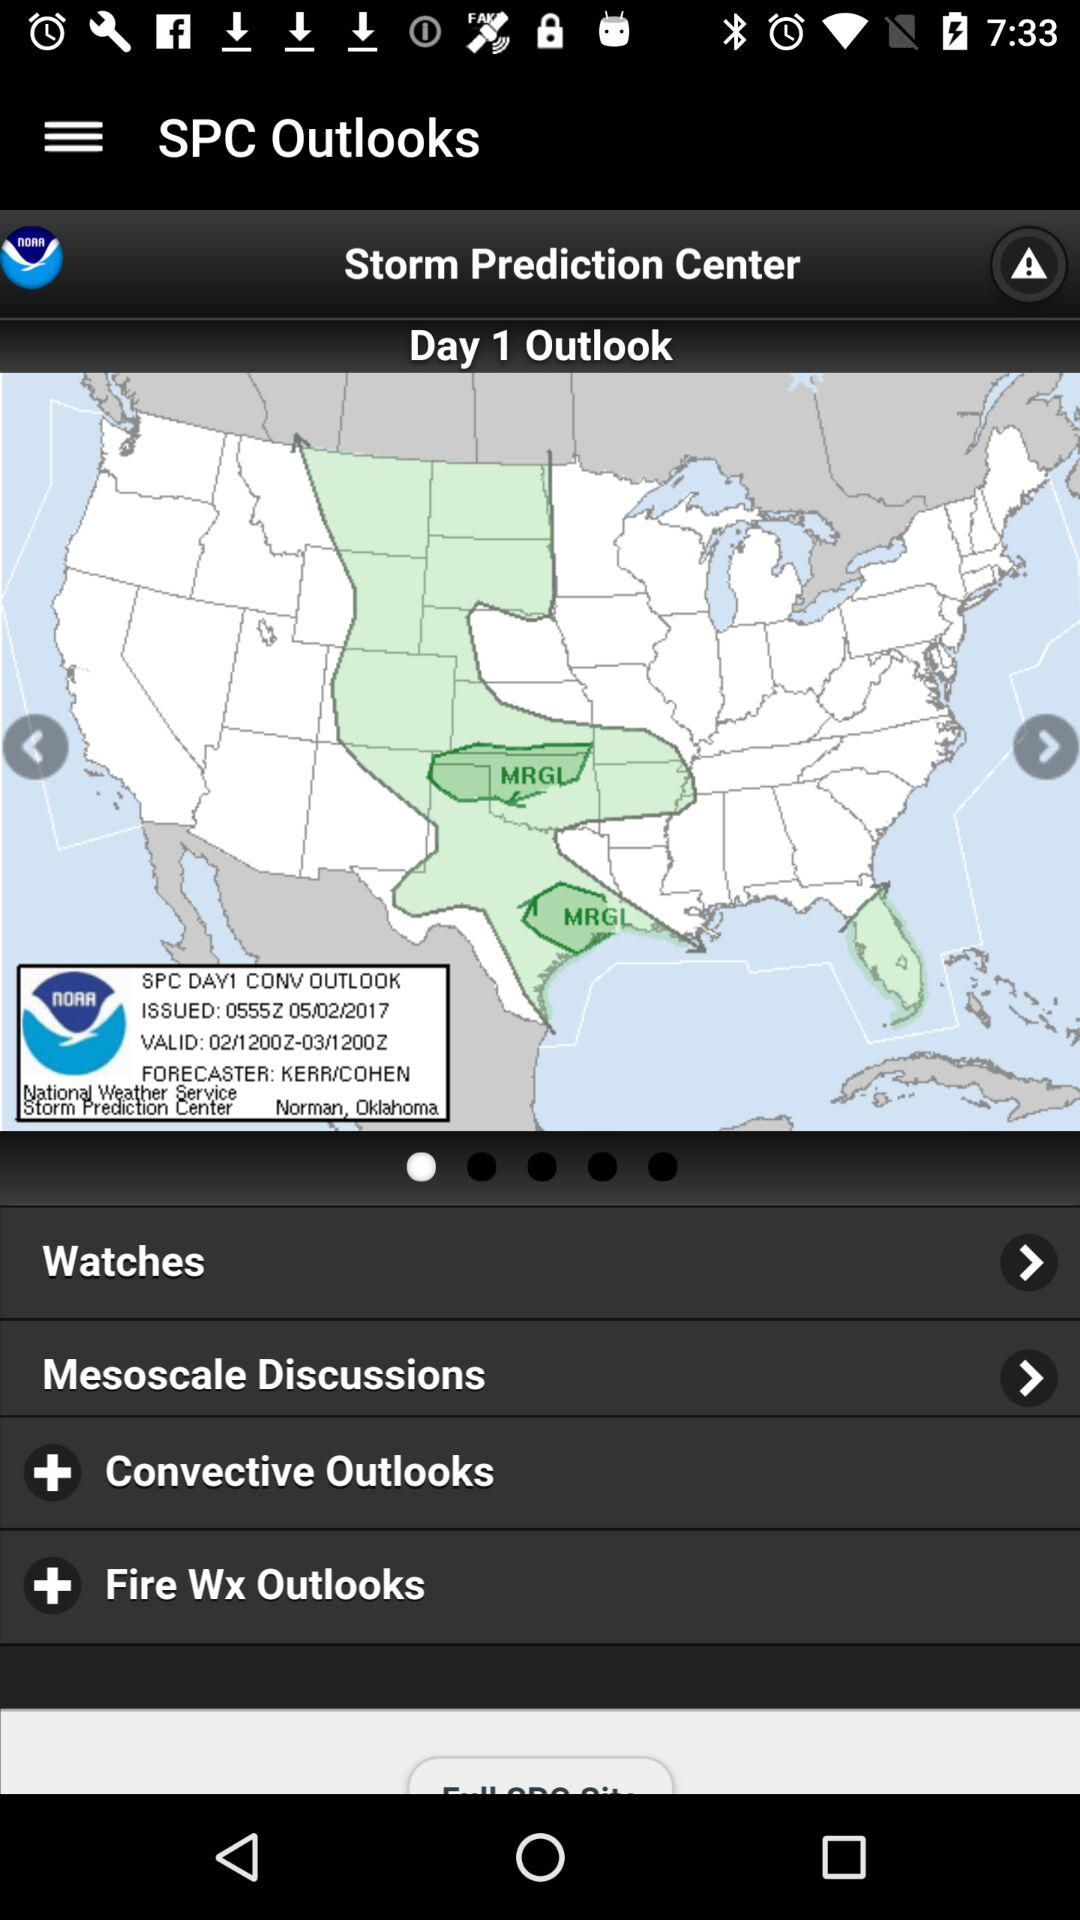What is the name of the application? The name of the application is "Storm Prediction Center". 